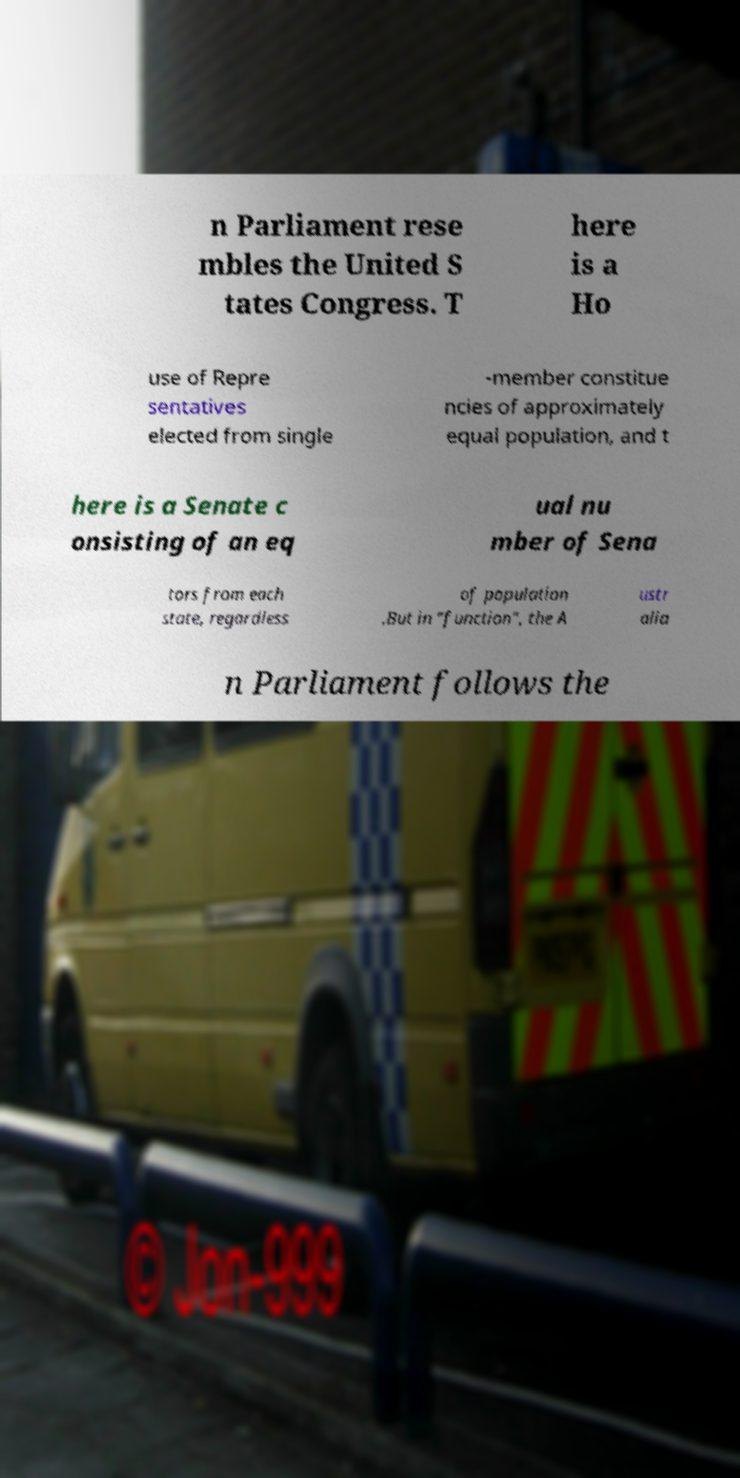I need the written content from this picture converted into text. Can you do that? n Parliament rese mbles the United S tates Congress. T here is a Ho use of Repre sentatives elected from single -member constitue ncies of approximately equal population, and t here is a Senate c onsisting of an eq ual nu mber of Sena tors from each state, regardless of population .But in "function", the A ustr alia n Parliament follows the 